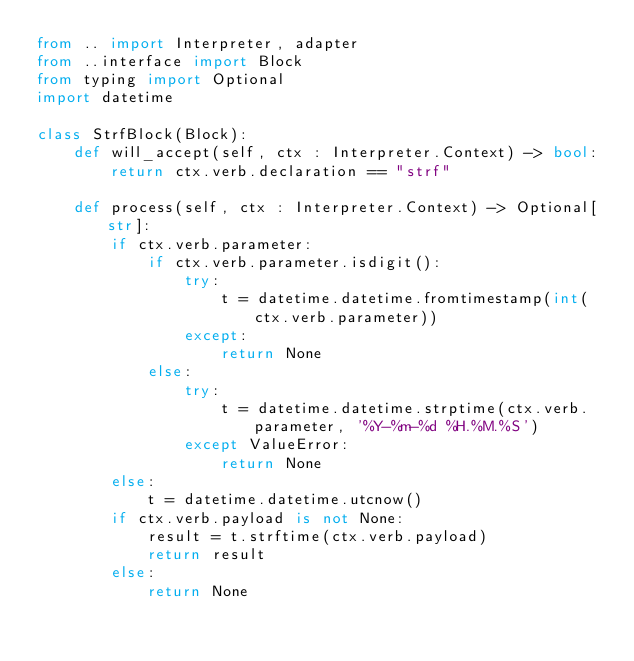<code> <loc_0><loc_0><loc_500><loc_500><_Python_>from .. import Interpreter, adapter
from ..interface import Block
from typing import Optional
import datetime

class StrfBlock(Block):
    def will_accept(self, ctx : Interpreter.Context) -> bool:
        return ctx.verb.declaration == "strf"

    def process(self, ctx : Interpreter.Context) -> Optional[str]:
        if ctx.verb.parameter:
            if ctx.verb.parameter.isdigit():
                try:
                    t = datetime.datetime.fromtimestamp(int(ctx.verb.parameter))
                except:
                    return None
            else:
                try:
                    t = datetime.datetime.strptime(ctx.verb.parameter, '%Y-%m-%d %H.%M.%S')
                except ValueError:
                    return None
        else:
            t = datetime.datetime.utcnow()
        if ctx.verb.payload is not None:
            result = t.strftime(ctx.verb.payload)
            return result
        else:
            return None
</code> 